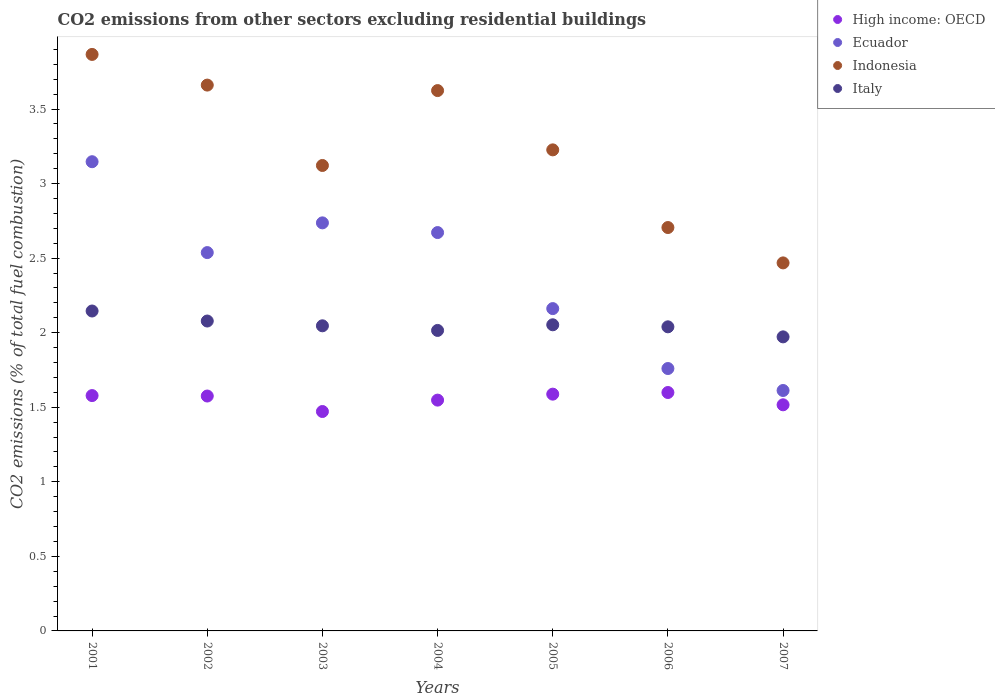How many different coloured dotlines are there?
Make the answer very short. 4. Is the number of dotlines equal to the number of legend labels?
Your answer should be compact. Yes. What is the total CO2 emitted in Indonesia in 2006?
Ensure brevity in your answer.  2.71. Across all years, what is the maximum total CO2 emitted in High income: OECD?
Provide a short and direct response. 1.6. Across all years, what is the minimum total CO2 emitted in High income: OECD?
Ensure brevity in your answer.  1.47. In which year was the total CO2 emitted in Indonesia maximum?
Offer a terse response. 2001. In which year was the total CO2 emitted in Ecuador minimum?
Provide a short and direct response. 2007. What is the total total CO2 emitted in Indonesia in the graph?
Your response must be concise. 22.67. What is the difference between the total CO2 emitted in Ecuador in 2002 and that in 2005?
Make the answer very short. 0.38. What is the difference between the total CO2 emitted in Italy in 2002 and the total CO2 emitted in Indonesia in 2003?
Give a very brief answer. -1.04. What is the average total CO2 emitted in Italy per year?
Give a very brief answer. 2.05. In the year 2006, what is the difference between the total CO2 emitted in High income: OECD and total CO2 emitted in Ecuador?
Give a very brief answer. -0.16. What is the ratio of the total CO2 emitted in High income: OECD in 2003 to that in 2004?
Keep it short and to the point. 0.95. Is the difference between the total CO2 emitted in High income: OECD in 2001 and 2005 greater than the difference between the total CO2 emitted in Ecuador in 2001 and 2005?
Ensure brevity in your answer.  No. What is the difference between the highest and the second highest total CO2 emitted in Italy?
Keep it short and to the point. 0.07. What is the difference between the highest and the lowest total CO2 emitted in Ecuador?
Provide a short and direct response. 1.53. In how many years, is the total CO2 emitted in Indonesia greater than the average total CO2 emitted in Indonesia taken over all years?
Give a very brief answer. 3. Is it the case that in every year, the sum of the total CO2 emitted in Italy and total CO2 emitted in Ecuador  is greater than the sum of total CO2 emitted in High income: OECD and total CO2 emitted in Indonesia?
Your response must be concise. No. Is it the case that in every year, the sum of the total CO2 emitted in High income: OECD and total CO2 emitted in Italy  is greater than the total CO2 emitted in Indonesia?
Offer a terse response. No. Does the total CO2 emitted in Indonesia monotonically increase over the years?
Provide a succinct answer. No. Is the total CO2 emitted in Ecuador strictly greater than the total CO2 emitted in High income: OECD over the years?
Make the answer very short. Yes. Is the total CO2 emitted in Ecuador strictly less than the total CO2 emitted in High income: OECD over the years?
Make the answer very short. No. How many years are there in the graph?
Your answer should be compact. 7. What is the difference between two consecutive major ticks on the Y-axis?
Give a very brief answer. 0.5. Are the values on the major ticks of Y-axis written in scientific E-notation?
Give a very brief answer. No. Where does the legend appear in the graph?
Offer a terse response. Top right. How many legend labels are there?
Keep it short and to the point. 4. How are the legend labels stacked?
Offer a very short reply. Vertical. What is the title of the graph?
Give a very brief answer. CO2 emissions from other sectors excluding residential buildings. Does "Spain" appear as one of the legend labels in the graph?
Provide a succinct answer. No. What is the label or title of the X-axis?
Provide a succinct answer. Years. What is the label or title of the Y-axis?
Offer a terse response. CO2 emissions (% of total fuel combustion). What is the CO2 emissions (% of total fuel combustion) of High income: OECD in 2001?
Offer a very short reply. 1.58. What is the CO2 emissions (% of total fuel combustion) of Ecuador in 2001?
Keep it short and to the point. 3.15. What is the CO2 emissions (% of total fuel combustion) of Indonesia in 2001?
Provide a short and direct response. 3.87. What is the CO2 emissions (% of total fuel combustion) of Italy in 2001?
Your answer should be compact. 2.15. What is the CO2 emissions (% of total fuel combustion) in High income: OECD in 2002?
Offer a terse response. 1.58. What is the CO2 emissions (% of total fuel combustion) in Ecuador in 2002?
Provide a short and direct response. 2.54. What is the CO2 emissions (% of total fuel combustion) of Indonesia in 2002?
Give a very brief answer. 3.66. What is the CO2 emissions (% of total fuel combustion) of Italy in 2002?
Your response must be concise. 2.08. What is the CO2 emissions (% of total fuel combustion) of High income: OECD in 2003?
Your answer should be very brief. 1.47. What is the CO2 emissions (% of total fuel combustion) in Ecuador in 2003?
Provide a short and direct response. 2.74. What is the CO2 emissions (% of total fuel combustion) in Indonesia in 2003?
Make the answer very short. 3.12. What is the CO2 emissions (% of total fuel combustion) of Italy in 2003?
Make the answer very short. 2.05. What is the CO2 emissions (% of total fuel combustion) of High income: OECD in 2004?
Provide a succinct answer. 1.55. What is the CO2 emissions (% of total fuel combustion) in Ecuador in 2004?
Give a very brief answer. 2.67. What is the CO2 emissions (% of total fuel combustion) of Indonesia in 2004?
Make the answer very short. 3.62. What is the CO2 emissions (% of total fuel combustion) of Italy in 2004?
Your answer should be very brief. 2.02. What is the CO2 emissions (% of total fuel combustion) in High income: OECD in 2005?
Make the answer very short. 1.59. What is the CO2 emissions (% of total fuel combustion) of Ecuador in 2005?
Offer a terse response. 2.16. What is the CO2 emissions (% of total fuel combustion) of Indonesia in 2005?
Offer a very short reply. 3.23. What is the CO2 emissions (% of total fuel combustion) in Italy in 2005?
Ensure brevity in your answer.  2.05. What is the CO2 emissions (% of total fuel combustion) in High income: OECD in 2006?
Make the answer very short. 1.6. What is the CO2 emissions (% of total fuel combustion) of Ecuador in 2006?
Provide a short and direct response. 1.76. What is the CO2 emissions (% of total fuel combustion) of Indonesia in 2006?
Provide a succinct answer. 2.71. What is the CO2 emissions (% of total fuel combustion) of Italy in 2006?
Ensure brevity in your answer.  2.04. What is the CO2 emissions (% of total fuel combustion) in High income: OECD in 2007?
Your response must be concise. 1.52. What is the CO2 emissions (% of total fuel combustion) of Ecuador in 2007?
Offer a very short reply. 1.61. What is the CO2 emissions (% of total fuel combustion) in Indonesia in 2007?
Offer a terse response. 2.47. What is the CO2 emissions (% of total fuel combustion) in Italy in 2007?
Provide a short and direct response. 1.97. Across all years, what is the maximum CO2 emissions (% of total fuel combustion) in High income: OECD?
Give a very brief answer. 1.6. Across all years, what is the maximum CO2 emissions (% of total fuel combustion) in Ecuador?
Provide a short and direct response. 3.15. Across all years, what is the maximum CO2 emissions (% of total fuel combustion) in Indonesia?
Your response must be concise. 3.87. Across all years, what is the maximum CO2 emissions (% of total fuel combustion) of Italy?
Offer a very short reply. 2.15. Across all years, what is the minimum CO2 emissions (% of total fuel combustion) in High income: OECD?
Your answer should be compact. 1.47. Across all years, what is the minimum CO2 emissions (% of total fuel combustion) of Ecuador?
Keep it short and to the point. 1.61. Across all years, what is the minimum CO2 emissions (% of total fuel combustion) of Indonesia?
Ensure brevity in your answer.  2.47. Across all years, what is the minimum CO2 emissions (% of total fuel combustion) of Italy?
Ensure brevity in your answer.  1.97. What is the total CO2 emissions (% of total fuel combustion) in High income: OECD in the graph?
Provide a succinct answer. 10.88. What is the total CO2 emissions (% of total fuel combustion) of Ecuador in the graph?
Keep it short and to the point. 16.62. What is the total CO2 emissions (% of total fuel combustion) in Indonesia in the graph?
Give a very brief answer. 22.67. What is the total CO2 emissions (% of total fuel combustion) of Italy in the graph?
Provide a short and direct response. 14.35. What is the difference between the CO2 emissions (% of total fuel combustion) of High income: OECD in 2001 and that in 2002?
Your response must be concise. 0. What is the difference between the CO2 emissions (% of total fuel combustion) in Ecuador in 2001 and that in 2002?
Provide a short and direct response. 0.61. What is the difference between the CO2 emissions (% of total fuel combustion) of Indonesia in 2001 and that in 2002?
Give a very brief answer. 0.21. What is the difference between the CO2 emissions (% of total fuel combustion) of Italy in 2001 and that in 2002?
Your answer should be very brief. 0.07. What is the difference between the CO2 emissions (% of total fuel combustion) of High income: OECD in 2001 and that in 2003?
Make the answer very short. 0.11. What is the difference between the CO2 emissions (% of total fuel combustion) in Ecuador in 2001 and that in 2003?
Provide a succinct answer. 0.41. What is the difference between the CO2 emissions (% of total fuel combustion) in Indonesia in 2001 and that in 2003?
Provide a succinct answer. 0.74. What is the difference between the CO2 emissions (% of total fuel combustion) in Italy in 2001 and that in 2003?
Provide a succinct answer. 0.1. What is the difference between the CO2 emissions (% of total fuel combustion) in High income: OECD in 2001 and that in 2004?
Your answer should be compact. 0.03. What is the difference between the CO2 emissions (% of total fuel combustion) in Ecuador in 2001 and that in 2004?
Offer a terse response. 0.48. What is the difference between the CO2 emissions (% of total fuel combustion) in Indonesia in 2001 and that in 2004?
Give a very brief answer. 0.24. What is the difference between the CO2 emissions (% of total fuel combustion) of Italy in 2001 and that in 2004?
Keep it short and to the point. 0.13. What is the difference between the CO2 emissions (% of total fuel combustion) of High income: OECD in 2001 and that in 2005?
Provide a succinct answer. -0.01. What is the difference between the CO2 emissions (% of total fuel combustion) in Ecuador in 2001 and that in 2005?
Provide a short and direct response. 0.98. What is the difference between the CO2 emissions (% of total fuel combustion) in Indonesia in 2001 and that in 2005?
Provide a succinct answer. 0.64. What is the difference between the CO2 emissions (% of total fuel combustion) in Italy in 2001 and that in 2005?
Provide a succinct answer. 0.09. What is the difference between the CO2 emissions (% of total fuel combustion) of High income: OECD in 2001 and that in 2006?
Give a very brief answer. -0.02. What is the difference between the CO2 emissions (% of total fuel combustion) in Ecuador in 2001 and that in 2006?
Keep it short and to the point. 1.39. What is the difference between the CO2 emissions (% of total fuel combustion) of Indonesia in 2001 and that in 2006?
Offer a terse response. 1.16. What is the difference between the CO2 emissions (% of total fuel combustion) of Italy in 2001 and that in 2006?
Your answer should be compact. 0.11. What is the difference between the CO2 emissions (% of total fuel combustion) in High income: OECD in 2001 and that in 2007?
Provide a succinct answer. 0.06. What is the difference between the CO2 emissions (% of total fuel combustion) of Ecuador in 2001 and that in 2007?
Give a very brief answer. 1.53. What is the difference between the CO2 emissions (% of total fuel combustion) of Indonesia in 2001 and that in 2007?
Your answer should be very brief. 1.4. What is the difference between the CO2 emissions (% of total fuel combustion) of Italy in 2001 and that in 2007?
Offer a very short reply. 0.17. What is the difference between the CO2 emissions (% of total fuel combustion) in High income: OECD in 2002 and that in 2003?
Keep it short and to the point. 0.1. What is the difference between the CO2 emissions (% of total fuel combustion) of Ecuador in 2002 and that in 2003?
Offer a very short reply. -0.2. What is the difference between the CO2 emissions (% of total fuel combustion) in Indonesia in 2002 and that in 2003?
Keep it short and to the point. 0.54. What is the difference between the CO2 emissions (% of total fuel combustion) in Italy in 2002 and that in 2003?
Offer a very short reply. 0.03. What is the difference between the CO2 emissions (% of total fuel combustion) of High income: OECD in 2002 and that in 2004?
Offer a very short reply. 0.03. What is the difference between the CO2 emissions (% of total fuel combustion) in Ecuador in 2002 and that in 2004?
Your response must be concise. -0.13. What is the difference between the CO2 emissions (% of total fuel combustion) of Indonesia in 2002 and that in 2004?
Ensure brevity in your answer.  0.04. What is the difference between the CO2 emissions (% of total fuel combustion) of Italy in 2002 and that in 2004?
Offer a very short reply. 0.06. What is the difference between the CO2 emissions (% of total fuel combustion) in High income: OECD in 2002 and that in 2005?
Your response must be concise. -0.01. What is the difference between the CO2 emissions (% of total fuel combustion) in Ecuador in 2002 and that in 2005?
Provide a succinct answer. 0.38. What is the difference between the CO2 emissions (% of total fuel combustion) of Indonesia in 2002 and that in 2005?
Offer a very short reply. 0.43. What is the difference between the CO2 emissions (% of total fuel combustion) of Italy in 2002 and that in 2005?
Your response must be concise. 0.03. What is the difference between the CO2 emissions (% of total fuel combustion) of High income: OECD in 2002 and that in 2006?
Your response must be concise. -0.02. What is the difference between the CO2 emissions (% of total fuel combustion) of Ecuador in 2002 and that in 2006?
Provide a short and direct response. 0.78. What is the difference between the CO2 emissions (% of total fuel combustion) of Indonesia in 2002 and that in 2006?
Ensure brevity in your answer.  0.96. What is the difference between the CO2 emissions (% of total fuel combustion) of Italy in 2002 and that in 2006?
Provide a succinct answer. 0.04. What is the difference between the CO2 emissions (% of total fuel combustion) of High income: OECD in 2002 and that in 2007?
Give a very brief answer. 0.06. What is the difference between the CO2 emissions (% of total fuel combustion) of Ecuador in 2002 and that in 2007?
Keep it short and to the point. 0.92. What is the difference between the CO2 emissions (% of total fuel combustion) in Indonesia in 2002 and that in 2007?
Offer a terse response. 1.19. What is the difference between the CO2 emissions (% of total fuel combustion) in Italy in 2002 and that in 2007?
Your response must be concise. 0.11. What is the difference between the CO2 emissions (% of total fuel combustion) of High income: OECD in 2003 and that in 2004?
Make the answer very short. -0.08. What is the difference between the CO2 emissions (% of total fuel combustion) in Ecuador in 2003 and that in 2004?
Your answer should be very brief. 0.07. What is the difference between the CO2 emissions (% of total fuel combustion) in Indonesia in 2003 and that in 2004?
Provide a short and direct response. -0.5. What is the difference between the CO2 emissions (% of total fuel combustion) in Italy in 2003 and that in 2004?
Offer a very short reply. 0.03. What is the difference between the CO2 emissions (% of total fuel combustion) in High income: OECD in 2003 and that in 2005?
Give a very brief answer. -0.12. What is the difference between the CO2 emissions (% of total fuel combustion) of Ecuador in 2003 and that in 2005?
Ensure brevity in your answer.  0.57. What is the difference between the CO2 emissions (% of total fuel combustion) of Indonesia in 2003 and that in 2005?
Your answer should be compact. -0.1. What is the difference between the CO2 emissions (% of total fuel combustion) of Italy in 2003 and that in 2005?
Give a very brief answer. -0.01. What is the difference between the CO2 emissions (% of total fuel combustion) of High income: OECD in 2003 and that in 2006?
Your response must be concise. -0.13. What is the difference between the CO2 emissions (% of total fuel combustion) in Ecuador in 2003 and that in 2006?
Keep it short and to the point. 0.98. What is the difference between the CO2 emissions (% of total fuel combustion) of Indonesia in 2003 and that in 2006?
Offer a terse response. 0.42. What is the difference between the CO2 emissions (% of total fuel combustion) of Italy in 2003 and that in 2006?
Make the answer very short. 0.01. What is the difference between the CO2 emissions (% of total fuel combustion) in High income: OECD in 2003 and that in 2007?
Give a very brief answer. -0.04. What is the difference between the CO2 emissions (% of total fuel combustion) in Ecuador in 2003 and that in 2007?
Keep it short and to the point. 1.12. What is the difference between the CO2 emissions (% of total fuel combustion) of Indonesia in 2003 and that in 2007?
Your answer should be very brief. 0.65. What is the difference between the CO2 emissions (% of total fuel combustion) of Italy in 2003 and that in 2007?
Keep it short and to the point. 0.07. What is the difference between the CO2 emissions (% of total fuel combustion) of High income: OECD in 2004 and that in 2005?
Provide a short and direct response. -0.04. What is the difference between the CO2 emissions (% of total fuel combustion) in Ecuador in 2004 and that in 2005?
Provide a short and direct response. 0.51. What is the difference between the CO2 emissions (% of total fuel combustion) in Indonesia in 2004 and that in 2005?
Make the answer very short. 0.4. What is the difference between the CO2 emissions (% of total fuel combustion) of Italy in 2004 and that in 2005?
Your response must be concise. -0.04. What is the difference between the CO2 emissions (% of total fuel combustion) in High income: OECD in 2004 and that in 2006?
Give a very brief answer. -0.05. What is the difference between the CO2 emissions (% of total fuel combustion) of Ecuador in 2004 and that in 2006?
Keep it short and to the point. 0.91. What is the difference between the CO2 emissions (% of total fuel combustion) of Indonesia in 2004 and that in 2006?
Make the answer very short. 0.92. What is the difference between the CO2 emissions (% of total fuel combustion) of Italy in 2004 and that in 2006?
Your response must be concise. -0.02. What is the difference between the CO2 emissions (% of total fuel combustion) in High income: OECD in 2004 and that in 2007?
Your response must be concise. 0.03. What is the difference between the CO2 emissions (% of total fuel combustion) of Ecuador in 2004 and that in 2007?
Give a very brief answer. 1.06. What is the difference between the CO2 emissions (% of total fuel combustion) of Indonesia in 2004 and that in 2007?
Make the answer very short. 1.16. What is the difference between the CO2 emissions (% of total fuel combustion) in Italy in 2004 and that in 2007?
Your response must be concise. 0.04. What is the difference between the CO2 emissions (% of total fuel combustion) in High income: OECD in 2005 and that in 2006?
Make the answer very short. -0.01. What is the difference between the CO2 emissions (% of total fuel combustion) of Ecuador in 2005 and that in 2006?
Offer a very short reply. 0.4. What is the difference between the CO2 emissions (% of total fuel combustion) in Indonesia in 2005 and that in 2006?
Offer a terse response. 0.52. What is the difference between the CO2 emissions (% of total fuel combustion) of Italy in 2005 and that in 2006?
Ensure brevity in your answer.  0.01. What is the difference between the CO2 emissions (% of total fuel combustion) of High income: OECD in 2005 and that in 2007?
Provide a short and direct response. 0.07. What is the difference between the CO2 emissions (% of total fuel combustion) of Ecuador in 2005 and that in 2007?
Your answer should be very brief. 0.55. What is the difference between the CO2 emissions (% of total fuel combustion) in Indonesia in 2005 and that in 2007?
Keep it short and to the point. 0.76. What is the difference between the CO2 emissions (% of total fuel combustion) of Italy in 2005 and that in 2007?
Your response must be concise. 0.08. What is the difference between the CO2 emissions (% of total fuel combustion) of High income: OECD in 2006 and that in 2007?
Offer a terse response. 0.08. What is the difference between the CO2 emissions (% of total fuel combustion) in Ecuador in 2006 and that in 2007?
Your answer should be compact. 0.15. What is the difference between the CO2 emissions (% of total fuel combustion) of Indonesia in 2006 and that in 2007?
Provide a succinct answer. 0.24. What is the difference between the CO2 emissions (% of total fuel combustion) of Italy in 2006 and that in 2007?
Ensure brevity in your answer.  0.07. What is the difference between the CO2 emissions (% of total fuel combustion) of High income: OECD in 2001 and the CO2 emissions (% of total fuel combustion) of Ecuador in 2002?
Make the answer very short. -0.96. What is the difference between the CO2 emissions (% of total fuel combustion) in High income: OECD in 2001 and the CO2 emissions (% of total fuel combustion) in Indonesia in 2002?
Your answer should be very brief. -2.08. What is the difference between the CO2 emissions (% of total fuel combustion) in Ecuador in 2001 and the CO2 emissions (% of total fuel combustion) in Indonesia in 2002?
Make the answer very short. -0.51. What is the difference between the CO2 emissions (% of total fuel combustion) of Ecuador in 2001 and the CO2 emissions (% of total fuel combustion) of Italy in 2002?
Make the answer very short. 1.07. What is the difference between the CO2 emissions (% of total fuel combustion) of Indonesia in 2001 and the CO2 emissions (% of total fuel combustion) of Italy in 2002?
Make the answer very short. 1.79. What is the difference between the CO2 emissions (% of total fuel combustion) in High income: OECD in 2001 and the CO2 emissions (% of total fuel combustion) in Ecuador in 2003?
Your answer should be compact. -1.16. What is the difference between the CO2 emissions (% of total fuel combustion) in High income: OECD in 2001 and the CO2 emissions (% of total fuel combustion) in Indonesia in 2003?
Provide a short and direct response. -1.54. What is the difference between the CO2 emissions (% of total fuel combustion) of High income: OECD in 2001 and the CO2 emissions (% of total fuel combustion) of Italy in 2003?
Your response must be concise. -0.47. What is the difference between the CO2 emissions (% of total fuel combustion) in Ecuador in 2001 and the CO2 emissions (% of total fuel combustion) in Indonesia in 2003?
Your response must be concise. 0.03. What is the difference between the CO2 emissions (% of total fuel combustion) of Ecuador in 2001 and the CO2 emissions (% of total fuel combustion) of Italy in 2003?
Provide a short and direct response. 1.1. What is the difference between the CO2 emissions (% of total fuel combustion) in Indonesia in 2001 and the CO2 emissions (% of total fuel combustion) in Italy in 2003?
Your response must be concise. 1.82. What is the difference between the CO2 emissions (% of total fuel combustion) in High income: OECD in 2001 and the CO2 emissions (% of total fuel combustion) in Ecuador in 2004?
Ensure brevity in your answer.  -1.09. What is the difference between the CO2 emissions (% of total fuel combustion) of High income: OECD in 2001 and the CO2 emissions (% of total fuel combustion) of Indonesia in 2004?
Offer a very short reply. -2.05. What is the difference between the CO2 emissions (% of total fuel combustion) of High income: OECD in 2001 and the CO2 emissions (% of total fuel combustion) of Italy in 2004?
Keep it short and to the point. -0.44. What is the difference between the CO2 emissions (% of total fuel combustion) in Ecuador in 2001 and the CO2 emissions (% of total fuel combustion) in Indonesia in 2004?
Ensure brevity in your answer.  -0.48. What is the difference between the CO2 emissions (% of total fuel combustion) in Ecuador in 2001 and the CO2 emissions (% of total fuel combustion) in Italy in 2004?
Offer a terse response. 1.13. What is the difference between the CO2 emissions (% of total fuel combustion) in Indonesia in 2001 and the CO2 emissions (% of total fuel combustion) in Italy in 2004?
Give a very brief answer. 1.85. What is the difference between the CO2 emissions (% of total fuel combustion) in High income: OECD in 2001 and the CO2 emissions (% of total fuel combustion) in Ecuador in 2005?
Provide a succinct answer. -0.58. What is the difference between the CO2 emissions (% of total fuel combustion) of High income: OECD in 2001 and the CO2 emissions (% of total fuel combustion) of Indonesia in 2005?
Offer a terse response. -1.65. What is the difference between the CO2 emissions (% of total fuel combustion) of High income: OECD in 2001 and the CO2 emissions (% of total fuel combustion) of Italy in 2005?
Your answer should be very brief. -0.47. What is the difference between the CO2 emissions (% of total fuel combustion) of Ecuador in 2001 and the CO2 emissions (% of total fuel combustion) of Indonesia in 2005?
Offer a very short reply. -0.08. What is the difference between the CO2 emissions (% of total fuel combustion) in Ecuador in 2001 and the CO2 emissions (% of total fuel combustion) in Italy in 2005?
Keep it short and to the point. 1.09. What is the difference between the CO2 emissions (% of total fuel combustion) of Indonesia in 2001 and the CO2 emissions (% of total fuel combustion) of Italy in 2005?
Your answer should be very brief. 1.81. What is the difference between the CO2 emissions (% of total fuel combustion) of High income: OECD in 2001 and the CO2 emissions (% of total fuel combustion) of Ecuador in 2006?
Your answer should be compact. -0.18. What is the difference between the CO2 emissions (% of total fuel combustion) of High income: OECD in 2001 and the CO2 emissions (% of total fuel combustion) of Indonesia in 2006?
Give a very brief answer. -1.13. What is the difference between the CO2 emissions (% of total fuel combustion) in High income: OECD in 2001 and the CO2 emissions (% of total fuel combustion) in Italy in 2006?
Provide a short and direct response. -0.46. What is the difference between the CO2 emissions (% of total fuel combustion) of Ecuador in 2001 and the CO2 emissions (% of total fuel combustion) of Indonesia in 2006?
Provide a succinct answer. 0.44. What is the difference between the CO2 emissions (% of total fuel combustion) in Ecuador in 2001 and the CO2 emissions (% of total fuel combustion) in Italy in 2006?
Provide a succinct answer. 1.11. What is the difference between the CO2 emissions (% of total fuel combustion) in Indonesia in 2001 and the CO2 emissions (% of total fuel combustion) in Italy in 2006?
Keep it short and to the point. 1.83. What is the difference between the CO2 emissions (% of total fuel combustion) in High income: OECD in 2001 and the CO2 emissions (% of total fuel combustion) in Ecuador in 2007?
Your answer should be compact. -0.03. What is the difference between the CO2 emissions (% of total fuel combustion) in High income: OECD in 2001 and the CO2 emissions (% of total fuel combustion) in Indonesia in 2007?
Keep it short and to the point. -0.89. What is the difference between the CO2 emissions (% of total fuel combustion) of High income: OECD in 2001 and the CO2 emissions (% of total fuel combustion) of Italy in 2007?
Your answer should be very brief. -0.39. What is the difference between the CO2 emissions (% of total fuel combustion) of Ecuador in 2001 and the CO2 emissions (% of total fuel combustion) of Indonesia in 2007?
Provide a short and direct response. 0.68. What is the difference between the CO2 emissions (% of total fuel combustion) in Ecuador in 2001 and the CO2 emissions (% of total fuel combustion) in Italy in 2007?
Your answer should be compact. 1.17. What is the difference between the CO2 emissions (% of total fuel combustion) in Indonesia in 2001 and the CO2 emissions (% of total fuel combustion) in Italy in 2007?
Keep it short and to the point. 1.89. What is the difference between the CO2 emissions (% of total fuel combustion) of High income: OECD in 2002 and the CO2 emissions (% of total fuel combustion) of Ecuador in 2003?
Your response must be concise. -1.16. What is the difference between the CO2 emissions (% of total fuel combustion) in High income: OECD in 2002 and the CO2 emissions (% of total fuel combustion) in Indonesia in 2003?
Offer a very short reply. -1.55. What is the difference between the CO2 emissions (% of total fuel combustion) of High income: OECD in 2002 and the CO2 emissions (% of total fuel combustion) of Italy in 2003?
Keep it short and to the point. -0.47. What is the difference between the CO2 emissions (% of total fuel combustion) in Ecuador in 2002 and the CO2 emissions (% of total fuel combustion) in Indonesia in 2003?
Make the answer very short. -0.58. What is the difference between the CO2 emissions (% of total fuel combustion) in Ecuador in 2002 and the CO2 emissions (% of total fuel combustion) in Italy in 2003?
Ensure brevity in your answer.  0.49. What is the difference between the CO2 emissions (% of total fuel combustion) of Indonesia in 2002 and the CO2 emissions (% of total fuel combustion) of Italy in 2003?
Provide a succinct answer. 1.61. What is the difference between the CO2 emissions (% of total fuel combustion) in High income: OECD in 2002 and the CO2 emissions (% of total fuel combustion) in Ecuador in 2004?
Your answer should be compact. -1.1. What is the difference between the CO2 emissions (% of total fuel combustion) of High income: OECD in 2002 and the CO2 emissions (% of total fuel combustion) of Indonesia in 2004?
Provide a succinct answer. -2.05. What is the difference between the CO2 emissions (% of total fuel combustion) in High income: OECD in 2002 and the CO2 emissions (% of total fuel combustion) in Italy in 2004?
Make the answer very short. -0.44. What is the difference between the CO2 emissions (% of total fuel combustion) in Ecuador in 2002 and the CO2 emissions (% of total fuel combustion) in Indonesia in 2004?
Your answer should be compact. -1.09. What is the difference between the CO2 emissions (% of total fuel combustion) of Ecuador in 2002 and the CO2 emissions (% of total fuel combustion) of Italy in 2004?
Make the answer very short. 0.52. What is the difference between the CO2 emissions (% of total fuel combustion) of Indonesia in 2002 and the CO2 emissions (% of total fuel combustion) of Italy in 2004?
Give a very brief answer. 1.65. What is the difference between the CO2 emissions (% of total fuel combustion) in High income: OECD in 2002 and the CO2 emissions (% of total fuel combustion) in Ecuador in 2005?
Provide a short and direct response. -0.59. What is the difference between the CO2 emissions (% of total fuel combustion) in High income: OECD in 2002 and the CO2 emissions (% of total fuel combustion) in Indonesia in 2005?
Provide a short and direct response. -1.65. What is the difference between the CO2 emissions (% of total fuel combustion) in High income: OECD in 2002 and the CO2 emissions (% of total fuel combustion) in Italy in 2005?
Your answer should be very brief. -0.48. What is the difference between the CO2 emissions (% of total fuel combustion) in Ecuador in 2002 and the CO2 emissions (% of total fuel combustion) in Indonesia in 2005?
Keep it short and to the point. -0.69. What is the difference between the CO2 emissions (% of total fuel combustion) in Ecuador in 2002 and the CO2 emissions (% of total fuel combustion) in Italy in 2005?
Keep it short and to the point. 0.48. What is the difference between the CO2 emissions (% of total fuel combustion) in Indonesia in 2002 and the CO2 emissions (% of total fuel combustion) in Italy in 2005?
Your answer should be compact. 1.61. What is the difference between the CO2 emissions (% of total fuel combustion) in High income: OECD in 2002 and the CO2 emissions (% of total fuel combustion) in Ecuador in 2006?
Ensure brevity in your answer.  -0.18. What is the difference between the CO2 emissions (% of total fuel combustion) in High income: OECD in 2002 and the CO2 emissions (% of total fuel combustion) in Indonesia in 2006?
Offer a terse response. -1.13. What is the difference between the CO2 emissions (% of total fuel combustion) of High income: OECD in 2002 and the CO2 emissions (% of total fuel combustion) of Italy in 2006?
Provide a short and direct response. -0.46. What is the difference between the CO2 emissions (% of total fuel combustion) in Ecuador in 2002 and the CO2 emissions (% of total fuel combustion) in Indonesia in 2006?
Your answer should be very brief. -0.17. What is the difference between the CO2 emissions (% of total fuel combustion) of Ecuador in 2002 and the CO2 emissions (% of total fuel combustion) of Italy in 2006?
Ensure brevity in your answer.  0.5. What is the difference between the CO2 emissions (% of total fuel combustion) in Indonesia in 2002 and the CO2 emissions (% of total fuel combustion) in Italy in 2006?
Provide a succinct answer. 1.62. What is the difference between the CO2 emissions (% of total fuel combustion) in High income: OECD in 2002 and the CO2 emissions (% of total fuel combustion) in Ecuador in 2007?
Your answer should be very brief. -0.04. What is the difference between the CO2 emissions (% of total fuel combustion) of High income: OECD in 2002 and the CO2 emissions (% of total fuel combustion) of Indonesia in 2007?
Offer a terse response. -0.89. What is the difference between the CO2 emissions (% of total fuel combustion) in High income: OECD in 2002 and the CO2 emissions (% of total fuel combustion) in Italy in 2007?
Keep it short and to the point. -0.4. What is the difference between the CO2 emissions (% of total fuel combustion) of Ecuador in 2002 and the CO2 emissions (% of total fuel combustion) of Indonesia in 2007?
Provide a short and direct response. 0.07. What is the difference between the CO2 emissions (% of total fuel combustion) in Ecuador in 2002 and the CO2 emissions (% of total fuel combustion) in Italy in 2007?
Ensure brevity in your answer.  0.57. What is the difference between the CO2 emissions (% of total fuel combustion) of Indonesia in 2002 and the CO2 emissions (% of total fuel combustion) of Italy in 2007?
Provide a short and direct response. 1.69. What is the difference between the CO2 emissions (% of total fuel combustion) in High income: OECD in 2003 and the CO2 emissions (% of total fuel combustion) in Indonesia in 2004?
Your answer should be compact. -2.15. What is the difference between the CO2 emissions (% of total fuel combustion) of High income: OECD in 2003 and the CO2 emissions (% of total fuel combustion) of Italy in 2004?
Offer a very short reply. -0.54. What is the difference between the CO2 emissions (% of total fuel combustion) in Ecuador in 2003 and the CO2 emissions (% of total fuel combustion) in Indonesia in 2004?
Your answer should be compact. -0.89. What is the difference between the CO2 emissions (% of total fuel combustion) in Ecuador in 2003 and the CO2 emissions (% of total fuel combustion) in Italy in 2004?
Your answer should be very brief. 0.72. What is the difference between the CO2 emissions (% of total fuel combustion) in Indonesia in 2003 and the CO2 emissions (% of total fuel combustion) in Italy in 2004?
Your answer should be compact. 1.11. What is the difference between the CO2 emissions (% of total fuel combustion) of High income: OECD in 2003 and the CO2 emissions (% of total fuel combustion) of Ecuador in 2005?
Your answer should be compact. -0.69. What is the difference between the CO2 emissions (% of total fuel combustion) in High income: OECD in 2003 and the CO2 emissions (% of total fuel combustion) in Indonesia in 2005?
Keep it short and to the point. -1.75. What is the difference between the CO2 emissions (% of total fuel combustion) of High income: OECD in 2003 and the CO2 emissions (% of total fuel combustion) of Italy in 2005?
Give a very brief answer. -0.58. What is the difference between the CO2 emissions (% of total fuel combustion) of Ecuador in 2003 and the CO2 emissions (% of total fuel combustion) of Indonesia in 2005?
Give a very brief answer. -0.49. What is the difference between the CO2 emissions (% of total fuel combustion) of Ecuador in 2003 and the CO2 emissions (% of total fuel combustion) of Italy in 2005?
Your response must be concise. 0.68. What is the difference between the CO2 emissions (% of total fuel combustion) in Indonesia in 2003 and the CO2 emissions (% of total fuel combustion) in Italy in 2005?
Provide a short and direct response. 1.07. What is the difference between the CO2 emissions (% of total fuel combustion) in High income: OECD in 2003 and the CO2 emissions (% of total fuel combustion) in Ecuador in 2006?
Give a very brief answer. -0.29. What is the difference between the CO2 emissions (% of total fuel combustion) of High income: OECD in 2003 and the CO2 emissions (% of total fuel combustion) of Indonesia in 2006?
Keep it short and to the point. -1.23. What is the difference between the CO2 emissions (% of total fuel combustion) of High income: OECD in 2003 and the CO2 emissions (% of total fuel combustion) of Italy in 2006?
Give a very brief answer. -0.57. What is the difference between the CO2 emissions (% of total fuel combustion) of Ecuador in 2003 and the CO2 emissions (% of total fuel combustion) of Indonesia in 2006?
Provide a short and direct response. 0.03. What is the difference between the CO2 emissions (% of total fuel combustion) in Ecuador in 2003 and the CO2 emissions (% of total fuel combustion) in Italy in 2006?
Provide a succinct answer. 0.7. What is the difference between the CO2 emissions (% of total fuel combustion) of Indonesia in 2003 and the CO2 emissions (% of total fuel combustion) of Italy in 2006?
Give a very brief answer. 1.08. What is the difference between the CO2 emissions (% of total fuel combustion) of High income: OECD in 2003 and the CO2 emissions (% of total fuel combustion) of Ecuador in 2007?
Provide a short and direct response. -0.14. What is the difference between the CO2 emissions (% of total fuel combustion) of High income: OECD in 2003 and the CO2 emissions (% of total fuel combustion) of Indonesia in 2007?
Offer a terse response. -1. What is the difference between the CO2 emissions (% of total fuel combustion) in High income: OECD in 2003 and the CO2 emissions (% of total fuel combustion) in Italy in 2007?
Provide a short and direct response. -0.5. What is the difference between the CO2 emissions (% of total fuel combustion) in Ecuador in 2003 and the CO2 emissions (% of total fuel combustion) in Indonesia in 2007?
Give a very brief answer. 0.27. What is the difference between the CO2 emissions (% of total fuel combustion) in Ecuador in 2003 and the CO2 emissions (% of total fuel combustion) in Italy in 2007?
Your answer should be compact. 0.76. What is the difference between the CO2 emissions (% of total fuel combustion) of Indonesia in 2003 and the CO2 emissions (% of total fuel combustion) of Italy in 2007?
Keep it short and to the point. 1.15. What is the difference between the CO2 emissions (% of total fuel combustion) of High income: OECD in 2004 and the CO2 emissions (% of total fuel combustion) of Ecuador in 2005?
Keep it short and to the point. -0.61. What is the difference between the CO2 emissions (% of total fuel combustion) of High income: OECD in 2004 and the CO2 emissions (% of total fuel combustion) of Indonesia in 2005?
Offer a very short reply. -1.68. What is the difference between the CO2 emissions (% of total fuel combustion) of High income: OECD in 2004 and the CO2 emissions (% of total fuel combustion) of Italy in 2005?
Make the answer very short. -0.51. What is the difference between the CO2 emissions (% of total fuel combustion) in Ecuador in 2004 and the CO2 emissions (% of total fuel combustion) in Indonesia in 2005?
Provide a succinct answer. -0.55. What is the difference between the CO2 emissions (% of total fuel combustion) in Ecuador in 2004 and the CO2 emissions (% of total fuel combustion) in Italy in 2005?
Give a very brief answer. 0.62. What is the difference between the CO2 emissions (% of total fuel combustion) in Indonesia in 2004 and the CO2 emissions (% of total fuel combustion) in Italy in 2005?
Provide a succinct answer. 1.57. What is the difference between the CO2 emissions (% of total fuel combustion) of High income: OECD in 2004 and the CO2 emissions (% of total fuel combustion) of Ecuador in 2006?
Keep it short and to the point. -0.21. What is the difference between the CO2 emissions (% of total fuel combustion) in High income: OECD in 2004 and the CO2 emissions (% of total fuel combustion) in Indonesia in 2006?
Keep it short and to the point. -1.16. What is the difference between the CO2 emissions (% of total fuel combustion) of High income: OECD in 2004 and the CO2 emissions (% of total fuel combustion) of Italy in 2006?
Give a very brief answer. -0.49. What is the difference between the CO2 emissions (% of total fuel combustion) of Ecuador in 2004 and the CO2 emissions (% of total fuel combustion) of Indonesia in 2006?
Your answer should be very brief. -0.03. What is the difference between the CO2 emissions (% of total fuel combustion) in Ecuador in 2004 and the CO2 emissions (% of total fuel combustion) in Italy in 2006?
Keep it short and to the point. 0.63. What is the difference between the CO2 emissions (% of total fuel combustion) in Indonesia in 2004 and the CO2 emissions (% of total fuel combustion) in Italy in 2006?
Give a very brief answer. 1.58. What is the difference between the CO2 emissions (% of total fuel combustion) in High income: OECD in 2004 and the CO2 emissions (% of total fuel combustion) in Ecuador in 2007?
Offer a terse response. -0.06. What is the difference between the CO2 emissions (% of total fuel combustion) of High income: OECD in 2004 and the CO2 emissions (% of total fuel combustion) of Indonesia in 2007?
Offer a terse response. -0.92. What is the difference between the CO2 emissions (% of total fuel combustion) of High income: OECD in 2004 and the CO2 emissions (% of total fuel combustion) of Italy in 2007?
Make the answer very short. -0.42. What is the difference between the CO2 emissions (% of total fuel combustion) of Ecuador in 2004 and the CO2 emissions (% of total fuel combustion) of Indonesia in 2007?
Provide a succinct answer. 0.2. What is the difference between the CO2 emissions (% of total fuel combustion) of Ecuador in 2004 and the CO2 emissions (% of total fuel combustion) of Italy in 2007?
Provide a short and direct response. 0.7. What is the difference between the CO2 emissions (% of total fuel combustion) in Indonesia in 2004 and the CO2 emissions (% of total fuel combustion) in Italy in 2007?
Give a very brief answer. 1.65. What is the difference between the CO2 emissions (% of total fuel combustion) of High income: OECD in 2005 and the CO2 emissions (% of total fuel combustion) of Ecuador in 2006?
Make the answer very short. -0.17. What is the difference between the CO2 emissions (% of total fuel combustion) of High income: OECD in 2005 and the CO2 emissions (% of total fuel combustion) of Indonesia in 2006?
Make the answer very short. -1.12. What is the difference between the CO2 emissions (% of total fuel combustion) in High income: OECD in 2005 and the CO2 emissions (% of total fuel combustion) in Italy in 2006?
Keep it short and to the point. -0.45. What is the difference between the CO2 emissions (% of total fuel combustion) in Ecuador in 2005 and the CO2 emissions (% of total fuel combustion) in Indonesia in 2006?
Keep it short and to the point. -0.54. What is the difference between the CO2 emissions (% of total fuel combustion) in Ecuador in 2005 and the CO2 emissions (% of total fuel combustion) in Italy in 2006?
Provide a succinct answer. 0.12. What is the difference between the CO2 emissions (% of total fuel combustion) in Indonesia in 2005 and the CO2 emissions (% of total fuel combustion) in Italy in 2006?
Ensure brevity in your answer.  1.19. What is the difference between the CO2 emissions (% of total fuel combustion) of High income: OECD in 2005 and the CO2 emissions (% of total fuel combustion) of Ecuador in 2007?
Your answer should be compact. -0.02. What is the difference between the CO2 emissions (% of total fuel combustion) of High income: OECD in 2005 and the CO2 emissions (% of total fuel combustion) of Indonesia in 2007?
Provide a short and direct response. -0.88. What is the difference between the CO2 emissions (% of total fuel combustion) of High income: OECD in 2005 and the CO2 emissions (% of total fuel combustion) of Italy in 2007?
Keep it short and to the point. -0.38. What is the difference between the CO2 emissions (% of total fuel combustion) of Ecuador in 2005 and the CO2 emissions (% of total fuel combustion) of Indonesia in 2007?
Keep it short and to the point. -0.31. What is the difference between the CO2 emissions (% of total fuel combustion) of Ecuador in 2005 and the CO2 emissions (% of total fuel combustion) of Italy in 2007?
Provide a succinct answer. 0.19. What is the difference between the CO2 emissions (% of total fuel combustion) of Indonesia in 2005 and the CO2 emissions (% of total fuel combustion) of Italy in 2007?
Offer a very short reply. 1.25. What is the difference between the CO2 emissions (% of total fuel combustion) of High income: OECD in 2006 and the CO2 emissions (% of total fuel combustion) of Ecuador in 2007?
Your response must be concise. -0.01. What is the difference between the CO2 emissions (% of total fuel combustion) in High income: OECD in 2006 and the CO2 emissions (% of total fuel combustion) in Indonesia in 2007?
Your response must be concise. -0.87. What is the difference between the CO2 emissions (% of total fuel combustion) in High income: OECD in 2006 and the CO2 emissions (% of total fuel combustion) in Italy in 2007?
Offer a very short reply. -0.37. What is the difference between the CO2 emissions (% of total fuel combustion) in Ecuador in 2006 and the CO2 emissions (% of total fuel combustion) in Indonesia in 2007?
Make the answer very short. -0.71. What is the difference between the CO2 emissions (% of total fuel combustion) of Ecuador in 2006 and the CO2 emissions (% of total fuel combustion) of Italy in 2007?
Ensure brevity in your answer.  -0.21. What is the difference between the CO2 emissions (% of total fuel combustion) in Indonesia in 2006 and the CO2 emissions (% of total fuel combustion) in Italy in 2007?
Your response must be concise. 0.73. What is the average CO2 emissions (% of total fuel combustion) in High income: OECD per year?
Give a very brief answer. 1.55. What is the average CO2 emissions (% of total fuel combustion) of Ecuador per year?
Make the answer very short. 2.38. What is the average CO2 emissions (% of total fuel combustion) in Indonesia per year?
Your response must be concise. 3.24. What is the average CO2 emissions (% of total fuel combustion) of Italy per year?
Offer a very short reply. 2.05. In the year 2001, what is the difference between the CO2 emissions (% of total fuel combustion) of High income: OECD and CO2 emissions (% of total fuel combustion) of Ecuador?
Your answer should be very brief. -1.57. In the year 2001, what is the difference between the CO2 emissions (% of total fuel combustion) in High income: OECD and CO2 emissions (% of total fuel combustion) in Indonesia?
Your answer should be compact. -2.29. In the year 2001, what is the difference between the CO2 emissions (% of total fuel combustion) in High income: OECD and CO2 emissions (% of total fuel combustion) in Italy?
Your answer should be very brief. -0.57. In the year 2001, what is the difference between the CO2 emissions (% of total fuel combustion) in Ecuador and CO2 emissions (% of total fuel combustion) in Indonesia?
Your answer should be compact. -0.72. In the year 2001, what is the difference between the CO2 emissions (% of total fuel combustion) in Ecuador and CO2 emissions (% of total fuel combustion) in Italy?
Keep it short and to the point. 1. In the year 2001, what is the difference between the CO2 emissions (% of total fuel combustion) of Indonesia and CO2 emissions (% of total fuel combustion) of Italy?
Offer a very short reply. 1.72. In the year 2002, what is the difference between the CO2 emissions (% of total fuel combustion) in High income: OECD and CO2 emissions (% of total fuel combustion) in Ecuador?
Ensure brevity in your answer.  -0.96. In the year 2002, what is the difference between the CO2 emissions (% of total fuel combustion) of High income: OECD and CO2 emissions (% of total fuel combustion) of Indonesia?
Give a very brief answer. -2.09. In the year 2002, what is the difference between the CO2 emissions (% of total fuel combustion) in High income: OECD and CO2 emissions (% of total fuel combustion) in Italy?
Keep it short and to the point. -0.5. In the year 2002, what is the difference between the CO2 emissions (% of total fuel combustion) in Ecuador and CO2 emissions (% of total fuel combustion) in Indonesia?
Give a very brief answer. -1.12. In the year 2002, what is the difference between the CO2 emissions (% of total fuel combustion) of Ecuador and CO2 emissions (% of total fuel combustion) of Italy?
Provide a short and direct response. 0.46. In the year 2002, what is the difference between the CO2 emissions (% of total fuel combustion) of Indonesia and CO2 emissions (% of total fuel combustion) of Italy?
Provide a short and direct response. 1.58. In the year 2003, what is the difference between the CO2 emissions (% of total fuel combustion) in High income: OECD and CO2 emissions (% of total fuel combustion) in Ecuador?
Your answer should be very brief. -1.26. In the year 2003, what is the difference between the CO2 emissions (% of total fuel combustion) of High income: OECD and CO2 emissions (% of total fuel combustion) of Indonesia?
Ensure brevity in your answer.  -1.65. In the year 2003, what is the difference between the CO2 emissions (% of total fuel combustion) in High income: OECD and CO2 emissions (% of total fuel combustion) in Italy?
Offer a terse response. -0.57. In the year 2003, what is the difference between the CO2 emissions (% of total fuel combustion) of Ecuador and CO2 emissions (% of total fuel combustion) of Indonesia?
Offer a very short reply. -0.38. In the year 2003, what is the difference between the CO2 emissions (% of total fuel combustion) of Ecuador and CO2 emissions (% of total fuel combustion) of Italy?
Provide a succinct answer. 0.69. In the year 2003, what is the difference between the CO2 emissions (% of total fuel combustion) in Indonesia and CO2 emissions (% of total fuel combustion) in Italy?
Give a very brief answer. 1.08. In the year 2004, what is the difference between the CO2 emissions (% of total fuel combustion) of High income: OECD and CO2 emissions (% of total fuel combustion) of Ecuador?
Provide a short and direct response. -1.12. In the year 2004, what is the difference between the CO2 emissions (% of total fuel combustion) in High income: OECD and CO2 emissions (% of total fuel combustion) in Indonesia?
Keep it short and to the point. -2.08. In the year 2004, what is the difference between the CO2 emissions (% of total fuel combustion) of High income: OECD and CO2 emissions (% of total fuel combustion) of Italy?
Provide a succinct answer. -0.47. In the year 2004, what is the difference between the CO2 emissions (% of total fuel combustion) of Ecuador and CO2 emissions (% of total fuel combustion) of Indonesia?
Provide a succinct answer. -0.95. In the year 2004, what is the difference between the CO2 emissions (% of total fuel combustion) in Ecuador and CO2 emissions (% of total fuel combustion) in Italy?
Keep it short and to the point. 0.66. In the year 2004, what is the difference between the CO2 emissions (% of total fuel combustion) of Indonesia and CO2 emissions (% of total fuel combustion) of Italy?
Give a very brief answer. 1.61. In the year 2005, what is the difference between the CO2 emissions (% of total fuel combustion) in High income: OECD and CO2 emissions (% of total fuel combustion) in Ecuador?
Keep it short and to the point. -0.57. In the year 2005, what is the difference between the CO2 emissions (% of total fuel combustion) in High income: OECD and CO2 emissions (% of total fuel combustion) in Indonesia?
Provide a short and direct response. -1.64. In the year 2005, what is the difference between the CO2 emissions (% of total fuel combustion) in High income: OECD and CO2 emissions (% of total fuel combustion) in Italy?
Make the answer very short. -0.47. In the year 2005, what is the difference between the CO2 emissions (% of total fuel combustion) of Ecuador and CO2 emissions (% of total fuel combustion) of Indonesia?
Keep it short and to the point. -1.06. In the year 2005, what is the difference between the CO2 emissions (% of total fuel combustion) of Ecuador and CO2 emissions (% of total fuel combustion) of Italy?
Offer a very short reply. 0.11. In the year 2005, what is the difference between the CO2 emissions (% of total fuel combustion) in Indonesia and CO2 emissions (% of total fuel combustion) in Italy?
Provide a short and direct response. 1.17. In the year 2006, what is the difference between the CO2 emissions (% of total fuel combustion) in High income: OECD and CO2 emissions (% of total fuel combustion) in Ecuador?
Your response must be concise. -0.16. In the year 2006, what is the difference between the CO2 emissions (% of total fuel combustion) in High income: OECD and CO2 emissions (% of total fuel combustion) in Indonesia?
Offer a terse response. -1.11. In the year 2006, what is the difference between the CO2 emissions (% of total fuel combustion) of High income: OECD and CO2 emissions (% of total fuel combustion) of Italy?
Your answer should be compact. -0.44. In the year 2006, what is the difference between the CO2 emissions (% of total fuel combustion) in Ecuador and CO2 emissions (% of total fuel combustion) in Indonesia?
Your answer should be compact. -0.95. In the year 2006, what is the difference between the CO2 emissions (% of total fuel combustion) of Ecuador and CO2 emissions (% of total fuel combustion) of Italy?
Ensure brevity in your answer.  -0.28. In the year 2006, what is the difference between the CO2 emissions (% of total fuel combustion) in Indonesia and CO2 emissions (% of total fuel combustion) in Italy?
Keep it short and to the point. 0.67. In the year 2007, what is the difference between the CO2 emissions (% of total fuel combustion) of High income: OECD and CO2 emissions (% of total fuel combustion) of Ecuador?
Keep it short and to the point. -0.1. In the year 2007, what is the difference between the CO2 emissions (% of total fuel combustion) in High income: OECD and CO2 emissions (% of total fuel combustion) in Indonesia?
Ensure brevity in your answer.  -0.95. In the year 2007, what is the difference between the CO2 emissions (% of total fuel combustion) of High income: OECD and CO2 emissions (% of total fuel combustion) of Italy?
Your response must be concise. -0.46. In the year 2007, what is the difference between the CO2 emissions (% of total fuel combustion) of Ecuador and CO2 emissions (% of total fuel combustion) of Indonesia?
Provide a succinct answer. -0.86. In the year 2007, what is the difference between the CO2 emissions (% of total fuel combustion) of Ecuador and CO2 emissions (% of total fuel combustion) of Italy?
Keep it short and to the point. -0.36. In the year 2007, what is the difference between the CO2 emissions (% of total fuel combustion) of Indonesia and CO2 emissions (% of total fuel combustion) of Italy?
Provide a succinct answer. 0.5. What is the ratio of the CO2 emissions (% of total fuel combustion) in Ecuador in 2001 to that in 2002?
Offer a very short reply. 1.24. What is the ratio of the CO2 emissions (% of total fuel combustion) of Indonesia in 2001 to that in 2002?
Keep it short and to the point. 1.06. What is the ratio of the CO2 emissions (% of total fuel combustion) of Italy in 2001 to that in 2002?
Give a very brief answer. 1.03. What is the ratio of the CO2 emissions (% of total fuel combustion) of High income: OECD in 2001 to that in 2003?
Keep it short and to the point. 1.07. What is the ratio of the CO2 emissions (% of total fuel combustion) in Ecuador in 2001 to that in 2003?
Your response must be concise. 1.15. What is the ratio of the CO2 emissions (% of total fuel combustion) in Indonesia in 2001 to that in 2003?
Provide a succinct answer. 1.24. What is the ratio of the CO2 emissions (% of total fuel combustion) of Italy in 2001 to that in 2003?
Make the answer very short. 1.05. What is the ratio of the CO2 emissions (% of total fuel combustion) of High income: OECD in 2001 to that in 2004?
Provide a succinct answer. 1.02. What is the ratio of the CO2 emissions (% of total fuel combustion) of Ecuador in 2001 to that in 2004?
Keep it short and to the point. 1.18. What is the ratio of the CO2 emissions (% of total fuel combustion) of Indonesia in 2001 to that in 2004?
Give a very brief answer. 1.07. What is the ratio of the CO2 emissions (% of total fuel combustion) in Italy in 2001 to that in 2004?
Your answer should be compact. 1.06. What is the ratio of the CO2 emissions (% of total fuel combustion) in High income: OECD in 2001 to that in 2005?
Make the answer very short. 0.99. What is the ratio of the CO2 emissions (% of total fuel combustion) in Ecuador in 2001 to that in 2005?
Offer a very short reply. 1.46. What is the ratio of the CO2 emissions (% of total fuel combustion) of Indonesia in 2001 to that in 2005?
Offer a very short reply. 1.2. What is the ratio of the CO2 emissions (% of total fuel combustion) of Italy in 2001 to that in 2005?
Make the answer very short. 1.04. What is the ratio of the CO2 emissions (% of total fuel combustion) in High income: OECD in 2001 to that in 2006?
Keep it short and to the point. 0.99. What is the ratio of the CO2 emissions (% of total fuel combustion) of Ecuador in 2001 to that in 2006?
Provide a succinct answer. 1.79. What is the ratio of the CO2 emissions (% of total fuel combustion) of Indonesia in 2001 to that in 2006?
Make the answer very short. 1.43. What is the ratio of the CO2 emissions (% of total fuel combustion) in Italy in 2001 to that in 2006?
Your answer should be compact. 1.05. What is the ratio of the CO2 emissions (% of total fuel combustion) in High income: OECD in 2001 to that in 2007?
Ensure brevity in your answer.  1.04. What is the ratio of the CO2 emissions (% of total fuel combustion) in Ecuador in 2001 to that in 2007?
Offer a very short reply. 1.95. What is the ratio of the CO2 emissions (% of total fuel combustion) of Indonesia in 2001 to that in 2007?
Provide a short and direct response. 1.57. What is the ratio of the CO2 emissions (% of total fuel combustion) of Italy in 2001 to that in 2007?
Provide a succinct answer. 1.09. What is the ratio of the CO2 emissions (% of total fuel combustion) in High income: OECD in 2002 to that in 2003?
Your answer should be very brief. 1.07. What is the ratio of the CO2 emissions (% of total fuel combustion) of Ecuador in 2002 to that in 2003?
Provide a short and direct response. 0.93. What is the ratio of the CO2 emissions (% of total fuel combustion) of Indonesia in 2002 to that in 2003?
Your response must be concise. 1.17. What is the ratio of the CO2 emissions (% of total fuel combustion) in Italy in 2002 to that in 2003?
Your answer should be compact. 1.02. What is the ratio of the CO2 emissions (% of total fuel combustion) of High income: OECD in 2002 to that in 2004?
Provide a succinct answer. 1.02. What is the ratio of the CO2 emissions (% of total fuel combustion) in Ecuador in 2002 to that in 2004?
Your answer should be very brief. 0.95. What is the ratio of the CO2 emissions (% of total fuel combustion) of Indonesia in 2002 to that in 2004?
Make the answer very short. 1.01. What is the ratio of the CO2 emissions (% of total fuel combustion) in Italy in 2002 to that in 2004?
Your answer should be very brief. 1.03. What is the ratio of the CO2 emissions (% of total fuel combustion) of High income: OECD in 2002 to that in 2005?
Keep it short and to the point. 0.99. What is the ratio of the CO2 emissions (% of total fuel combustion) of Ecuador in 2002 to that in 2005?
Keep it short and to the point. 1.17. What is the ratio of the CO2 emissions (% of total fuel combustion) of Indonesia in 2002 to that in 2005?
Provide a succinct answer. 1.13. What is the ratio of the CO2 emissions (% of total fuel combustion) of Italy in 2002 to that in 2005?
Provide a succinct answer. 1.01. What is the ratio of the CO2 emissions (% of total fuel combustion) of High income: OECD in 2002 to that in 2006?
Ensure brevity in your answer.  0.99. What is the ratio of the CO2 emissions (% of total fuel combustion) of Ecuador in 2002 to that in 2006?
Offer a very short reply. 1.44. What is the ratio of the CO2 emissions (% of total fuel combustion) in Indonesia in 2002 to that in 2006?
Give a very brief answer. 1.35. What is the ratio of the CO2 emissions (% of total fuel combustion) of Italy in 2002 to that in 2006?
Your answer should be compact. 1.02. What is the ratio of the CO2 emissions (% of total fuel combustion) in High income: OECD in 2002 to that in 2007?
Offer a very short reply. 1.04. What is the ratio of the CO2 emissions (% of total fuel combustion) in Ecuador in 2002 to that in 2007?
Provide a succinct answer. 1.57. What is the ratio of the CO2 emissions (% of total fuel combustion) of Indonesia in 2002 to that in 2007?
Make the answer very short. 1.48. What is the ratio of the CO2 emissions (% of total fuel combustion) of Italy in 2002 to that in 2007?
Provide a succinct answer. 1.05. What is the ratio of the CO2 emissions (% of total fuel combustion) in High income: OECD in 2003 to that in 2004?
Provide a short and direct response. 0.95. What is the ratio of the CO2 emissions (% of total fuel combustion) of Ecuador in 2003 to that in 2004?
Offer a very short reply. 1.02. What is the ratio of the CO2 emissions (% of total fuel combustion) of Indonesia in 2003 to that in 2004?
Keep it short and to the point. 0.86. What is the ratio of the CO2 emissions (% of total fuel combustion) in Italy in 2003 to that in 2004?
Offer a very short reply. 1.02. What is the ratio of the CO2 emissions (% of total fuel combustion) of High income: OECD in 2003 to that in 2005?
Make the answer very short. 0.93. What is the ratio of the CO2 emissions (% of total fuel combustion) in Ecuador in 2003 to that in 2005?
Your response must be concise. 1.27. What is the ratio of the CO2 emissions (% of total fuel combustion) in Indonesia in 2003 to that in 2005?
Your answer should be compact. 0.97. What is the ratio of the CO2 emissions (% of total fuel combustion) of Italy in 2003 to that in 2005?
Ensure brevity in your answer.  1. What is the ratio of the CO2 emissions (% of total fuel combustion) in High income: OECD in 2003 to that in 2006?
Make the answer very short. 0.92. What is the ratio of the CO2 emissions (% of total fuel combustion) of Ecuador in 2003 to that in 2006?
Your response must be concise. 1.56. What is the ratio of the CO2 emissions (% of total fuel combustion) of Indonesia in 2003 to that in 2006?
Your response must be concise. 1.15. What is the ratio of the CO2 emissions (% of total fuel combustion) in Italy in 2003 to that in 2006?
Offer a terse response. 1. What is the ratio of the CO2 emissions (% of total fuel combustion) of High income: OECD in 2003 to that in 2007?
Provide a succinct answer. 0.97. What is the ratio of the CO2 emissions (% of total fuel combustion) of Ecuador in 2003 to that in 2007?
Your response must be concise. 1.7. What is the ratio of the CO2 emissions (% of total fuel combustion) in Indonesia in 2003 to that in 2007?
Make the answer very short. 1.26. What is the ratio of the CO2 emissions (% of total fuel combustion) in Italy in 2003 to that in 2007?
Ensure brevity in your answer.  1.04. What is the ratio of the CO2 emissions (% of total fuel combustion) of High income: OECD in 2004 to that in 2005?
Make the answer very short. 0.97. What is the ratio of the CO2 emissions (% of total fuel combustion) in Ecuador in 2004 to that in 2005?
Keep it short and to the point. 1.24. What is the ratio of the CO2 emissions (% of total fuel combustion) in Indonesia in 2004 to that in 2005?
Provide a short and direct response. 1.12. What is the ratio of the CO2 emissions (% of total fuel combustion) in Italy in 2004 to that in 2005?
Your response must be concise. 0.98. What is the ratio of the CO2 emissions (% of total fuel combustion) in High income: OECD in 2004 to that in 2006?
Provide a short and direct response. 0.97. What is the ratio of the CO2 emissions (% of total fuel combustion) of Ecuador in 2004 to that in 2006?
Your answer should be very brief. 1.52. What is the ratio of the CO2 emissions (% of total fuel combustion) of Indonesia in 2004 to that in 2006?
Your answer should be compact. 1.34. What is the ratio of the CO2 emissions (% of total fuel combustion) in Italy in 2004 to that in 2006?
Make the answer very short. 0.99. What is the ratio of the CO2 emissions (% of total fuel combustion) of High income: OECD in 2004 to that in 2007?
Your answer should be compact. 1.02. What is the ratio of the CO2 emissions (% of total fuel combustion) in Ecuador in 2004 to that in 2007?
Make the answer very short. 1.66. What is the ratio of the CO2 emissions (% of total fuel combustion) in Indonesia in 2004 to that in 2007?
Your answer should be compact. 1.47. What is the ratio of the CO2 emissions (% of total fuel combustion) in Italy in 2004 to that in 2007?
Keep it short and to the point. 1.02. What is the ratio of the CO2 emissions (% of total fuel combustion) of Ecuador in 2005 to that in 2006?
Offer a very short reply. 1.23. What is the ratio of the CO2 emissions (% of total fuel combustion) of Indonesia in 2005 to that in 2006?
Your response must be concise. 1.19. What is the ratio of the CO2 emissions (% of total fuel combustion) of High income: OECD in 2005 to that in 2007?
Make the answer very short. 1.05. What is the ratio of the CO2 emissions (% of total fuel combustion) of Ecuador in 2005 to that in 2007?
Offer a very short reply. 1.34. What is the ratio of the CO2 emissions (% of total fuel combustion) in Indonesia in 2005 to that in 2007?
Offer a very short reply. 1.31. What is the ratio of the CO2 emissions (% of total fuel combustion) of Italy in 2005 to that in 2007?
Make the answer very short. 1.04. What is the ratio of the CO2 emissions (% of total fuel combustion) of High income: OECD in 2006 to that in 2007?
Give a very brief answer. 1.05. What is the ratio of the CO2 emissions (% of total fuel combustion) of Ecuador in 2006 to that in 2007?
Keep it short and to the point. 1.09. What is the ratio of the CO2 emissions (% of total fuel combustion) in Indonesia in 2006 to that in 2007?
Offer a terse response. 1.1. What is the ratio of the CO2 emissions (% of total fuel combustion) in Italy in 2006 to that in 2007?
Make the answer very short. 1.03. What is the difference between the highest and the second highest CO2 emissions (% of total fuel combustion) of High income: OECD?
Give a very brief answer. 0.01. What is the difference between the highest and the second highest CO2 emissions (% of total fuel combustion) of Ecuador?
Your answer should be compact. 0.41. What is the difference between the highest and the second highest CO2 emissions (% of total fuel combustion) in Indonesia?
Offer a terse response. 0.21. What is the difference between the highest and the second highest CO2 emissions (% of total fuel combustion) in Italy?
Provide a succinct answer. 0.07. What is the difference between the highest and the lowest CO2 emissions (% of total fuel combustion) of High income: OECD?
Give a very brief answer. 0.13. What is the difference between the highest and the lowest CO2 emissions (% of total fuel combustion) in Ecuador?
Your response must be concise. 1.53. What is the difference between the highest and the lowest CO2 emissions (% of total fuel combustion) in Indonesia?
Provide a succinct answer. 1.4. What is the difference between the highest and the lowest CO2 emissions (% of total fuel combustion) of Italy?
Ensure brevity in your answer.  0.17. 